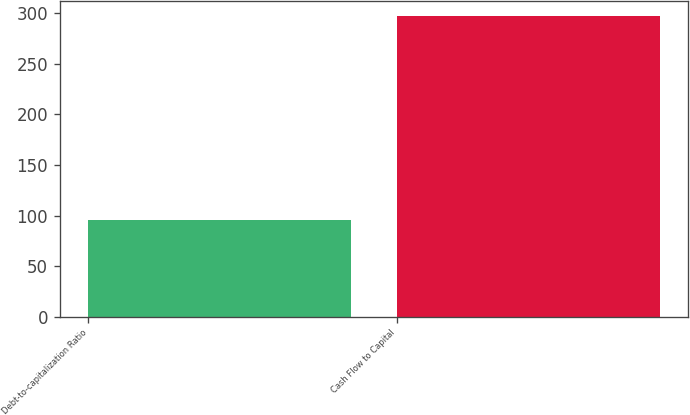Convert chart. <chart><loc_0><loc_0><loc_500><loc_500><bar_chart><fcel>Debt-to-capitalization Ratio<fcel>Cash Flow to Capital<nl><fcel>96<fcel>297<nl></chart> 